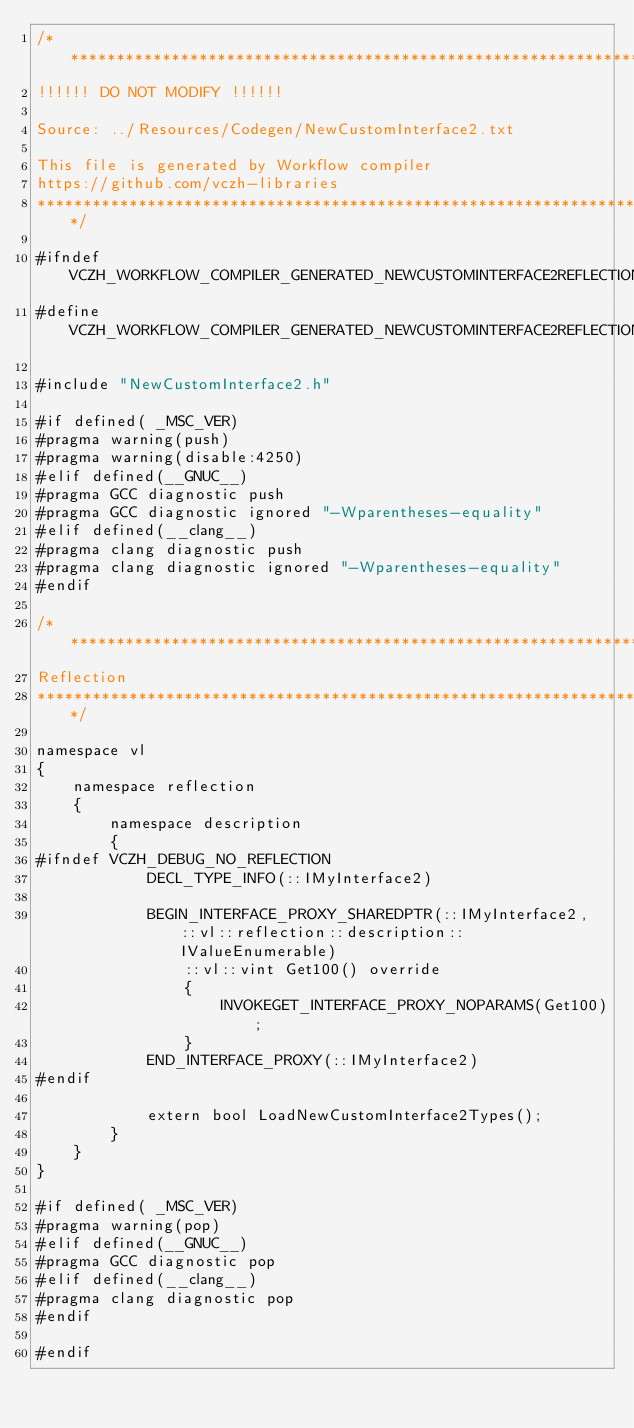<code> <loc_0><loc_0><loc_500><loc_500><_C_>/***********************************************************************
!!!!!! DO NOT MODIFY !!!!!!

Source: ../Resources/Codegen/NewCustomInterface2.txt

This file is generated by Workflow compiler
https://github.com/vczh-libraries
***********************************************************************/

#ifndef VCZH_WORKFLOW_COMPILER_GENERATED_NEWCUSTOMINTERFACE2REFLECTION
#define VCZH_WORKFLOW_COMPILER_GENERATED_NEWCUSTOMINTERFACE2REFLECTION

#include "NewCustomInterface2.h"

#if defined( _MSC_VER)
#pragma warning(push)
#pragma warning(disable:4250)
#elif defined(__GNUC__)
#pragma GCC diagnostic push
#pragma GCC diagnostic ignored "-Wparentheses-equality"
#elif defined(__clang__)
#pragma clang diagnostic push
#pragma clang diagnostic ignored "-Wparentheses-equality"
#endif

/***********************************************************************
Reflection
***********************************************************************/

namespace vl
{
	namespace reflection
	{
		namespace description
		{
#ifndef VCZH_DEBUG_NO_REFLECTION
			DECL_TYPE_INFO(::IMyInterface2)

			BEGIN_INTERFACE_PROXY_SHAREDPTR(::IMyInterface2, ::vl::reflection::description::IValueEnumerable)
				::vl::vint Get100() override
				{
					INVOKEGET_INTERFACE_PROXY_NOPARAMS(Get100);
				}
			END_INTERFACE_PROXY(::IMyInterface2)
#endif

			extern bool LoadNewCustomInterface2Types();
		}
	}
}

#if defined( _MSC_VER)
#pragma warning(pop)
#elif defined(__GNUC__)
#pragma GCC diagnostic pop
#elif defined(__clang__)
#pragma clang diagnostic pop
#endif

#endif
</code> 